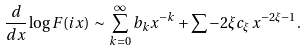Convert formula to latex. <formula><loc_0><loc_0><loc_500><loc_500>\frac { d } { d x } \log F ( i x ) \, \sim \, \sum _ { k = 0 } ^ { \infty } b _ { k } x ^ { - k } + \sum - 2 \xi c _ { \xi } \, x ^ { - 2 \xi - 1 } .</formula> 